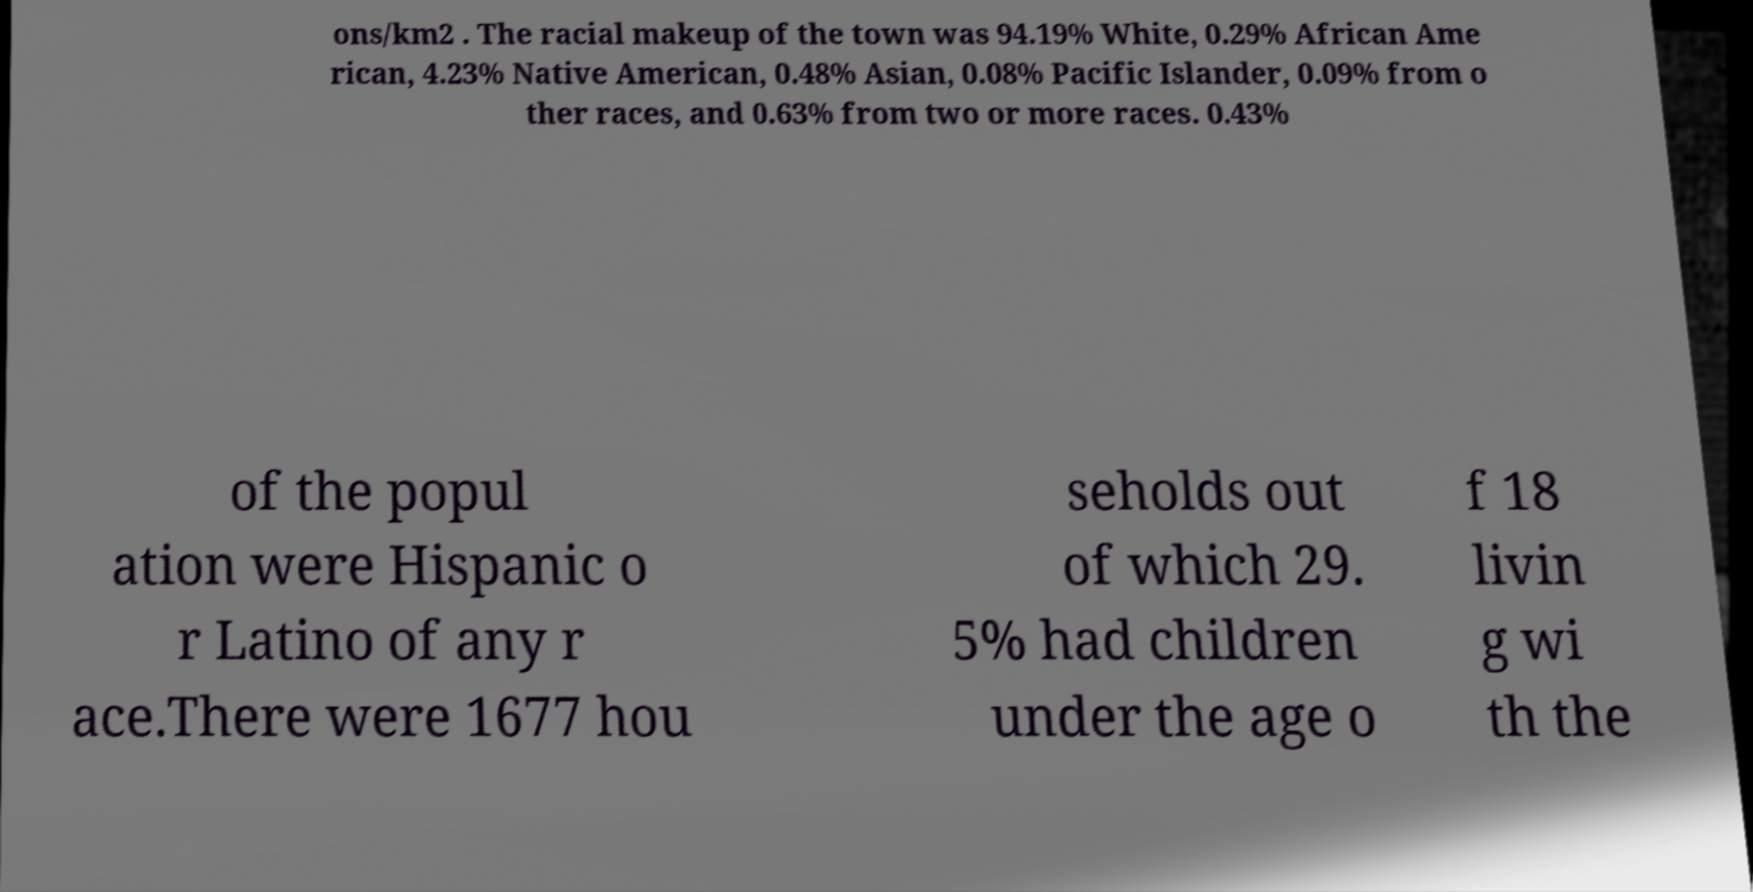Could you assist in decoding the text presented in this image and type it out clearly? ons/km2 . The racial makeup of the town was 94.19% White, 0.29% African Ame rican, 4.23% Native American, 0.48% Asian, 0.08% Pacific Islander, 0.09% from o ther races, and 0.63% from two or more races. 0.43% of the popul ation were Hispanic o r Latino of any r ace.There were 1677 hou seholds out of which 29. 5% had children under the age o f 18 livin g wi th the 